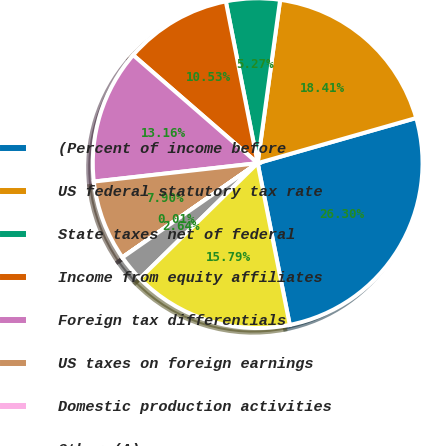Convert chart. <chart><loc_0><loc_0><loc_500><loc_500><pie_chart><fcel>(Percent of income before<fcel>US federal statutory tax rate<fcel>State taxes net of federal<fcel>Income from equity affiliates<fcel>Foreign tax differentials<fcel>US taxes on foreign earnings<fcel>Domestic production activities<fcel>Other (A)<fcel>Effective Tax Rate<nl><fcel>26.3%<fcel>18.41%<fcel>5.27%<fcel>10.53%<fcel>13.16%<fcel>7.9%<fcel>0.01%<fcel>2.64%<fcel>15.79%<nl></chart> 